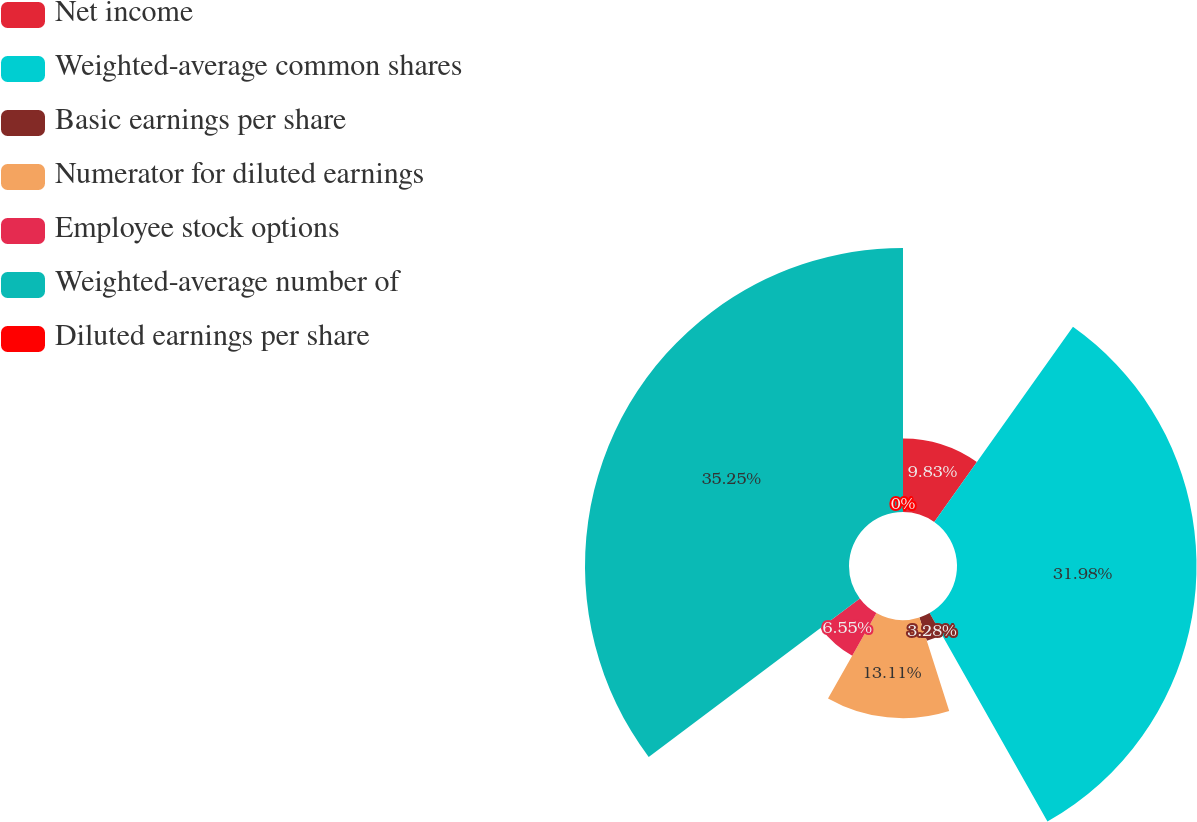<chart> <loc_0><loc_0><loc_500><loc_500><pie_chart><fcel>Net income<fcel>Weighted-average common shares<fcel>Basic earnings per share<fcel>Numerator for diluted earnings<fcel>Employee stock options<fcel>Weighted-average number of<fcel>Diluted earnings per share<nl><fcel>9.83%<fcel>31.98%<fcel>3.28%<fcel>13.11%<fcel>6.55%<fcel>35.25%<fcel>0.0%<nl></chart> 